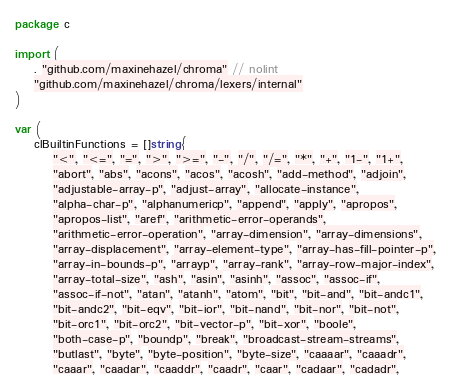<code> <loc_0><loc_0><loc_500><loc_500><_Go_>package c

import (
	. "github.com/maxinehazel/chroma" // nolint
	"github.com/maxinehazel/chroma/lexers/internal"
)

var (
	clBuiltinFunctions = []string{
		"<", "<=", "=", ">", ">=", "-", "/", "/=", "*", "+", "1-", "1+",
		"abort", "abs", "acons", "acos", "acosh", "add-method", "adjoin",
		"adjustable-array-p", "adjust-array", "allocate-instance",
		"alpha-char-p", "alphanumericp", "append", "apply", "apropos",
		"apropos-list", "aref", "arithmetic-error-operands",
		"arithmetic-error-operation", "array-dimension", "array-dimensions",
		"array-displacement", "array-element-type", "array-has-fill-pointer-p",
		"array-in-bounds-p", "arrayp", "array-rank", "array-row-major-index",
		"array-total-size", "ash", "asin", "asinh", "assoc", "assoc-if",
		"assoc-if-not", "atan", "atanh", "atom", "bit", "bit-and", "bit-andc1",
		"bit-andc2", "bit-eqv", "bit-ior", "bit-nand", "bit-nor", "bit-not",
		"bit-orc1", "bit-orc2", "bit-vector-p", "bit-xor", "boole",
		"both-case-p", "boundp", "break", "broadcast-stream-streams",
		"butlast", "byte", "byte-position", "byte-size", "caaaar", "caaadr",
		"caaar", "caadar", "caaddr", "caadr", "caar", "cadaar", "cadadr",</code> 